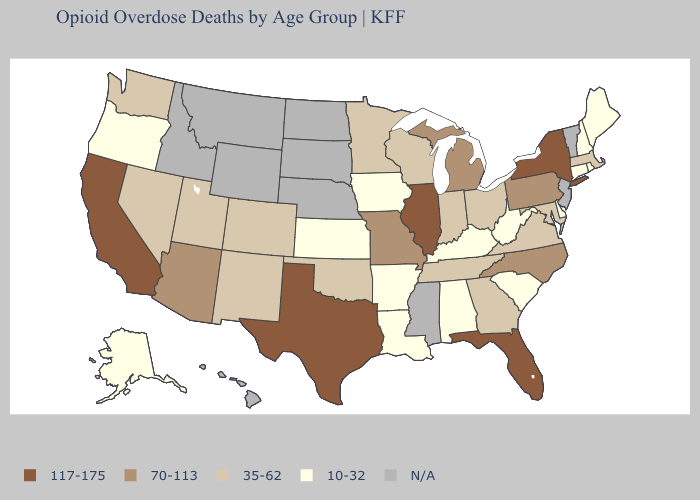What is the lowest value in the South?
Write a very short answer. 10-32. What is the lowest value in states that border Nevada?
Concise answer only. 10-32. Does California have the highest value in the USA?
Quick response, please. Yes. What is the value of Rhode Island?
Short answer required. 10-32. What is the value of Hawaii?
Answer briefly. N/A. Does the map have missing data?
Be succinct. Yes. How many symbols are there in the legend?
Give a very brief answer. 5. What is the highest value in states that border Wisconsin?
Be succinct. 117-175. Name the states that have a value in the range 10-32?
Give a very brief answer. Alabama, Alaska, Arkansas, Connecticut, Delaware, Iowa, Kansas, Kentucky, Louisiana, Maine, New Hampshire, Oregon, Rhode Island, South Carolina, West Virginia. What is the lowest value in the South?
Short answer required. 10-32. What is the value of Alabama?
Write a very short answer. 10-32. Does California have the highest value in the West?
Give a very brief answer. Yes. What is the lowest value in the West?
Be succinct. 10-32. Is the legend a continuous bar?
Give a very brief answer. No. Does the first symbol in the legend represent the smallest category?
Concise answer only. No. 